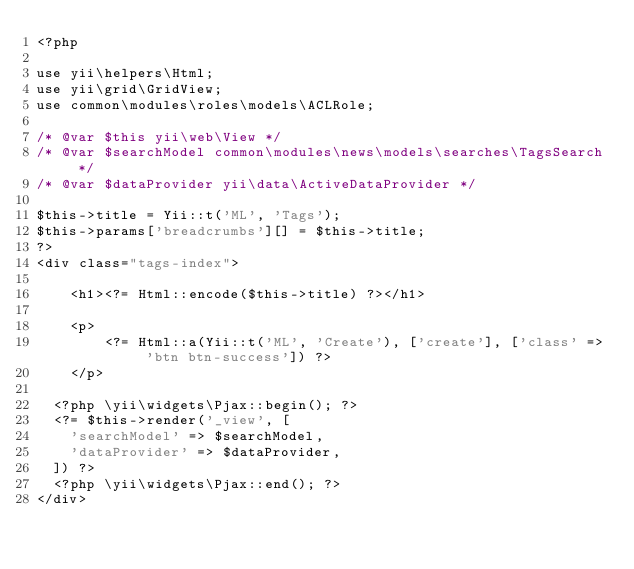Convert code to text. <code><loc_0><loc_0><loc_500><loc_500><_PHP_><?php

use yii\helpers\Html;
use yii\grid\GridView;
use common\modules\roles\models\ACLRole;

/* @var $this yii\web\View */
/* @var $searchModel common\modules\news\models\searches\TagsSearch */
/* @var $dataProvider yii\data\ActiveDataProvider */

$this->title = Yii::t('ML', 'Tags');
$this->params['breadcrumbs'][] = $this->title;
?>
<div class="tags-index">

    <h1><?= Html::encode($this->title) ?></h1>

    <p>
        <?= Html::a(Yii::t('ML', 'Create'), ['create'], ['class' => 'btn btn-success']) ?>
    </p>

	<?php \yii\widgets\Pjax::begin(); ?>	
	<?= $this->render('_view', [
		'searchModel' => $searchModel,
		'dataProvider' => $dataProvider,
	]) ?>
	<?php \yii\widgets\Pjax::end(); ?>	
</div>
</code> 